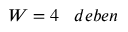Convert formula to latex. <formula><loc_0><loc_0><loc_500><loc_500>W = 4 \, d e b e n</formula> 